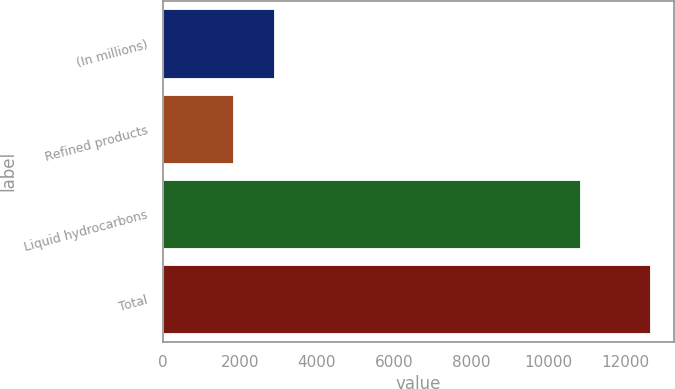Convert chart to OTSL. <chart><loc_0><loc_0><loc_500><loc_500><bar_chart><fcel>(In millions)<fcel>Refined products<fcel>Liquid hydrocarbons<fcel>Total<nl><fcel>2898.9<fcel>1817<fcel>10819<fcel>12636<nl></chart> 